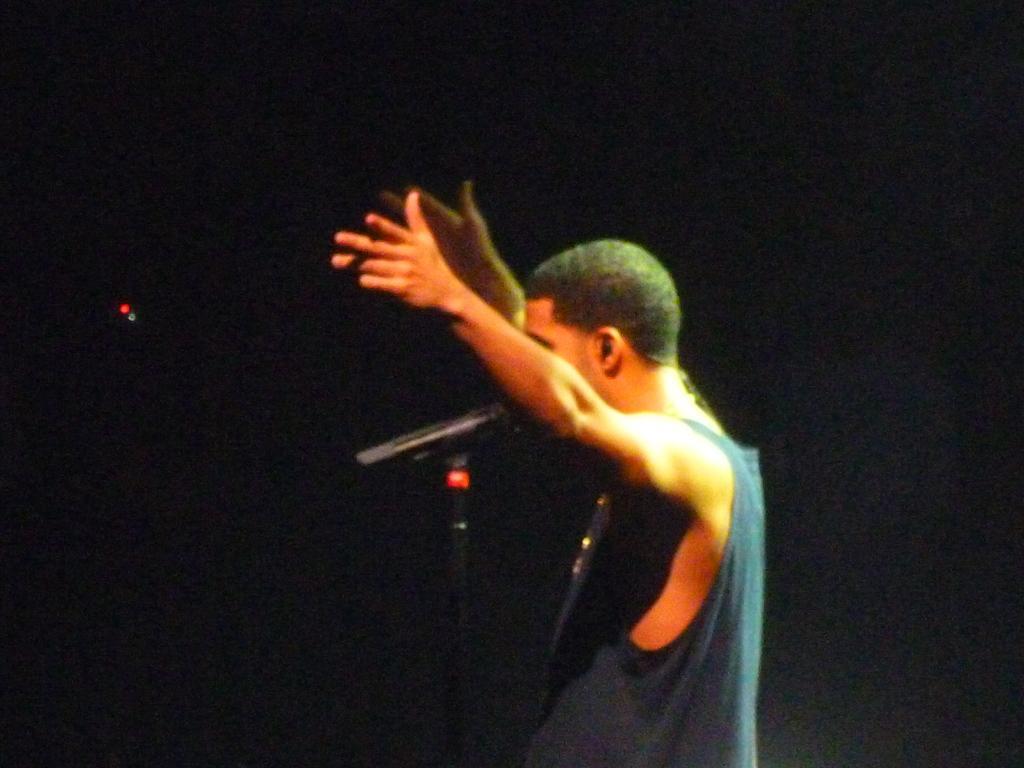Please provide a concise description of this image. Here I can see a man wearing a t-shirt, standing facing towards the left side and raising his hands up. In front of this man there is a mike stand. The background is dark. 